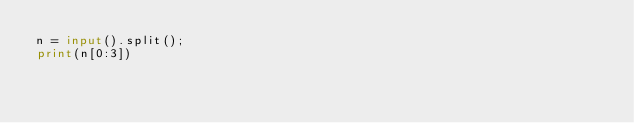Convert code to text. <code><loc_0><loc_0><loc_500><loc_500><_Python_>n = input().split();
print(n[0:3])</code> 